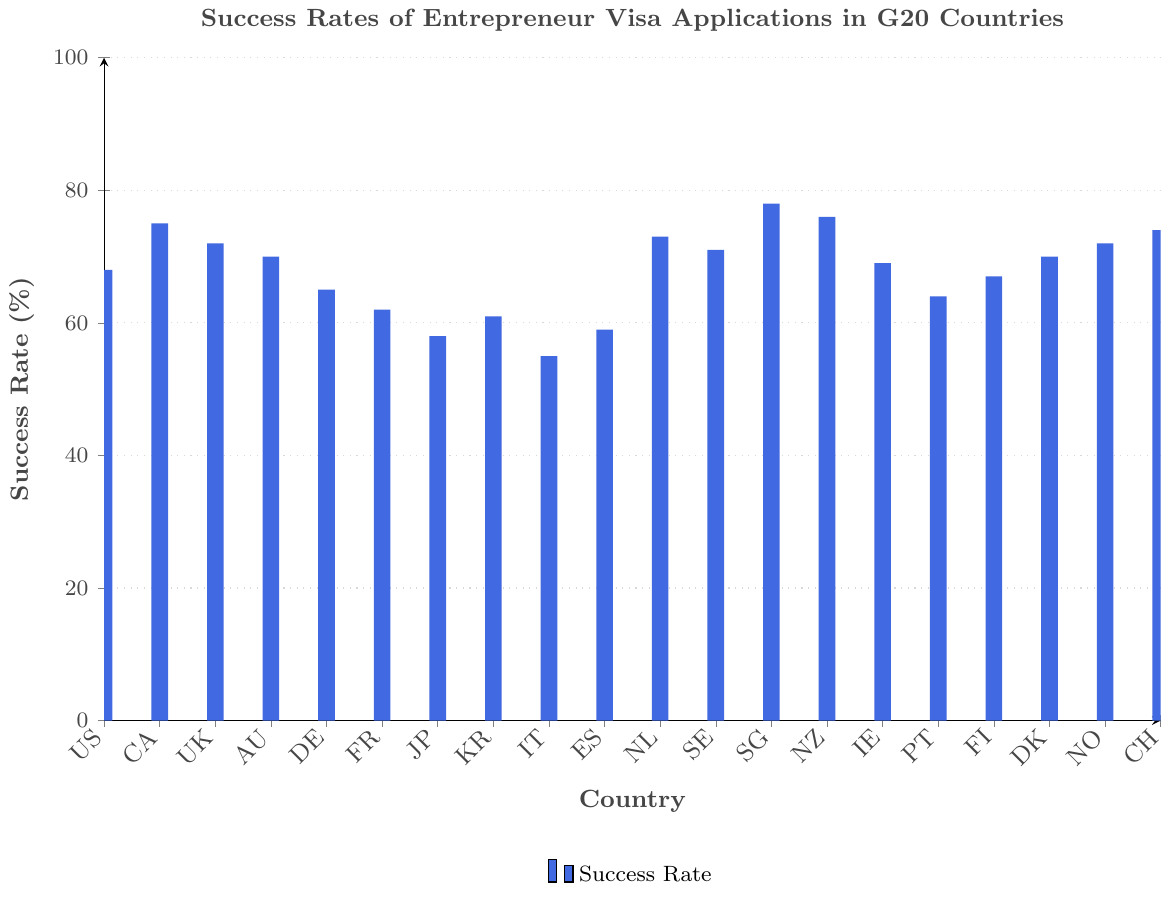Which country has the highest success rate for entrepreneur visa applications? The country with the highest bar in the chart represents the highest success rate. Looking at the bars, Singapore has the highest success rate.
Answer: Singapore Which country has the lowest success rate for entrepreneur visa applications? The country with the lowest bar in the chart represents the lowest success rate. Italy's bar is the shortest.
Answer: Italy What is the success rate for entrepreneur visa applications in the United Kingdom? Locate the bar labeled "UK" and read the value on the y-axis corresponding to it. The success rate is 72%.
Answer: 72% Which country has a higher success rate, Canada or Australia? Compare the heights of the bars labeled "CA" and "AU". Canada's bar is higher than Australia's.
Answer: Canada How does Germany's entrepreneur visa success rate compare to that of Spain? Locate the bars labeled "DE" and "ES" and compare their heights. Germany has a slightly higher success rate than Spain.
Answer: Germany What’s the average success rate for the countries with top rejection reasons related to insufficient business plans or lack of innovation? Identify the relevant countries (US and UK) and calculate their average success rate. (68+72)/2 = 70.
Answer: 70 Which countries have a success rate above 70%? Identify bars with heights above the 70% mark. These countries are Canada, United Kingdom, Netherlands, Sweden, Singapore, New Zealand, Norway, and Switzerland.
Answer: Canada, United Kingdom, Netherlands, Sweden, Singapore, New Zealand, Norway, Switzerland What is the difference in success rates between the country with the highest rate and the country with the lowest rate? Identify the highest (Singapore, 78%) and the lowest (Italy, 55%) success rates, then subtract the lowest from the highest. 78 - 55 = 23
Answer: 23 Which countries have success rates between 60% and 65%? Identify bars that fall within this range on the y-axis. These countries are Germany, France, South Korea, and Portugal.
Answer: Germany, France, South Korea, Portugal 